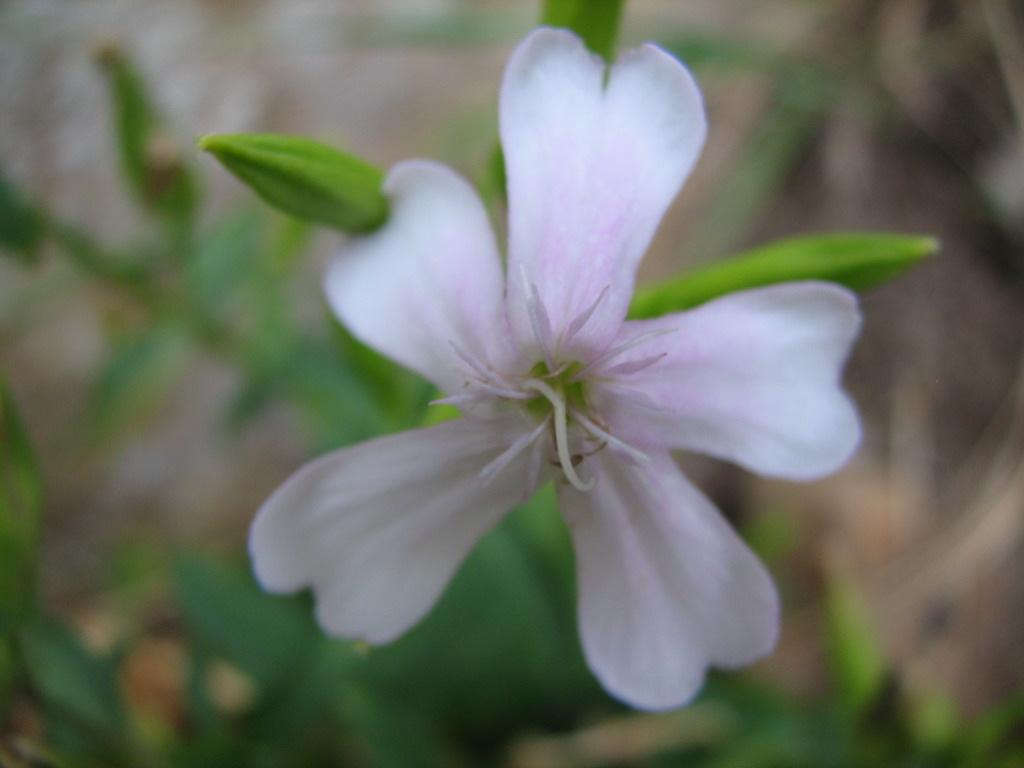What is the main subject of the image? There is a flower in the image. Can you describe the color of the flower? The flower is light pink in color. What can be seen in the background of the image? The background of the image is greenery. Is there a ring visible on the stem of the flower in the image? No, there is no ring visible on the stem of the flower in the image. Can you see any writing on the petals of the flower in the image? No, there is no writing on the petals of the flower in the image. 